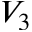<formula> <loc_0><loc_0><loc_500><loc_500>V _ { 3 }</formula> 